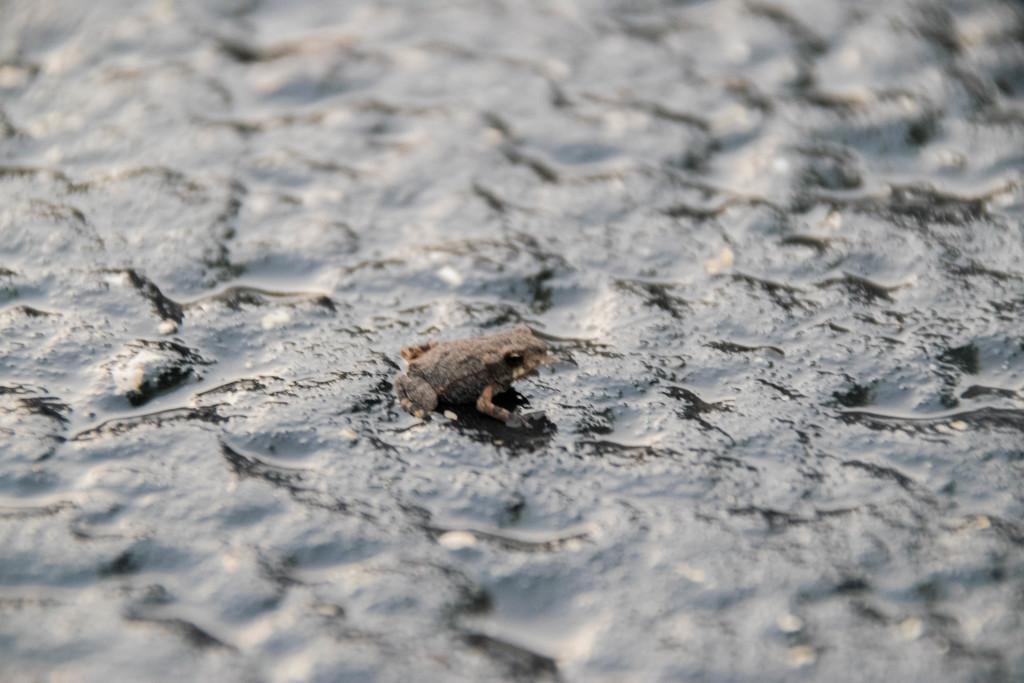Can you describe this image briefly? In this image, I can see a frog on the rock. 